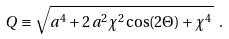Convert formula to latex. <formula><loc_0><loc_0><loc_500><loc_500>Q \equiv \sqrt { { a } ^ { 4 } + 2 \, { a } ^ { 2 } { \chi } ^ { 2 } \cos ( 2 \Theta ) + { \chi } ^ { 4 } \, } \ .</formula> 